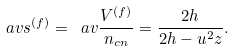Convert formula to latex. <formula><loc_0><loc_0><loc_500><loc_500>\ a v { s } ^ { ( f ) } = \ a v { \frac { V ^ { ( f ) } } { n _ { c n } } } = \frac { 2 h } { 2 h - u ^ { 2 } z } .</formula> 